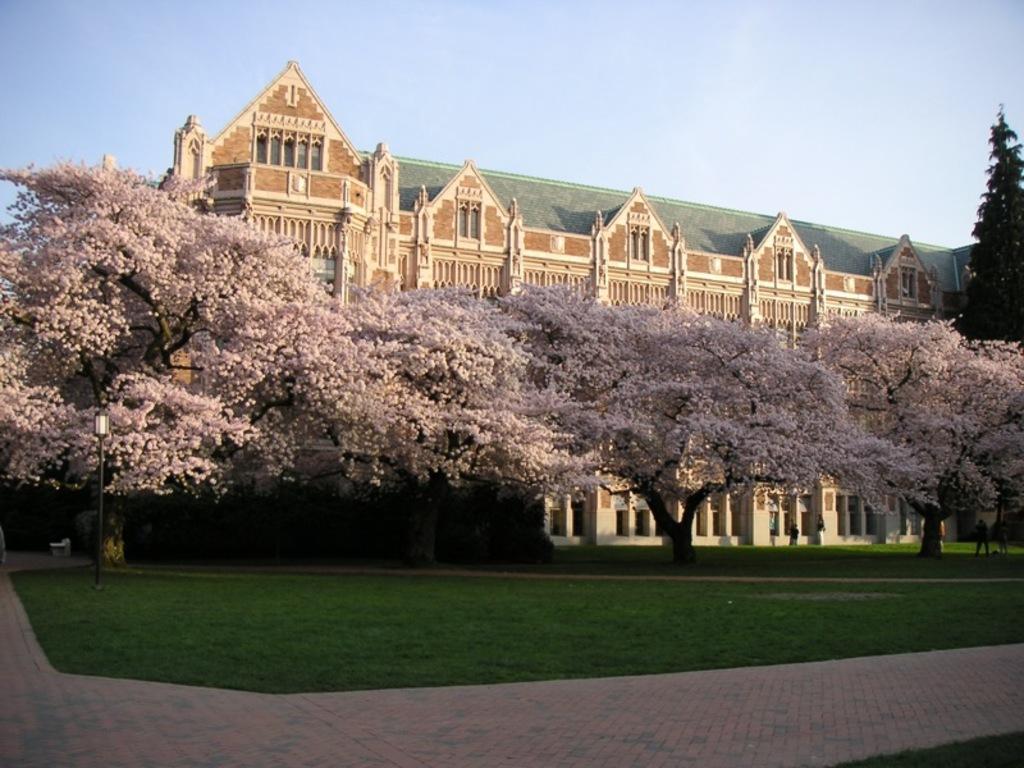In one or two sentences, can you explain what this image depicts? In this picture I can see building and few trees and I can see pole light and grass on the ground and I can see a blue cloudy sky. 